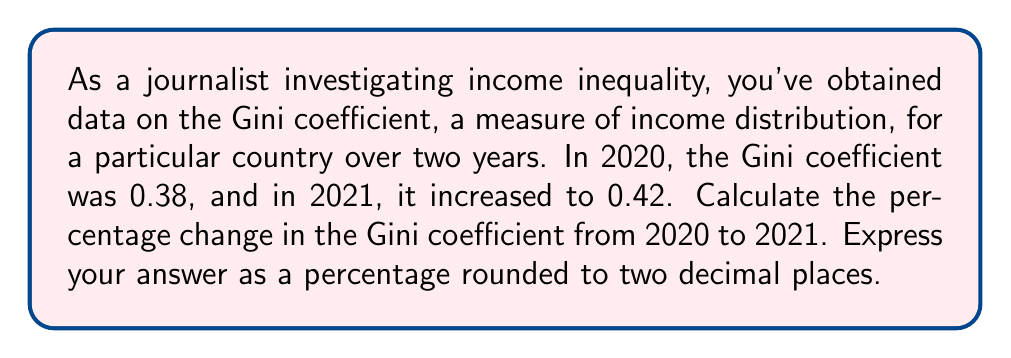Can you answer this question? To calculate the percentage change in the Gini coefficient, we'll use the following formula:

$$ \text{Percentage Change} = \frac{\text{New Value} - \text{Original Value}}{\text{Original Value}} \times 100\% $$

Let's plug in our values:
- Original Value (2020 Gini coefficient): 0.38
- New Value (2021 Gini coefficient): 0.42

$$ \text{Percentage Change} = \frac{0.42 - 0.38}{0.38} \times 100\% $$

$$ = \frac{0.04}{0.38} \times 100\% $$

$$ = 0.10526... \times 100\% $$

$$ = 10.526...\% $$

Rounding to two decimal places, we get 10.53%.

This increase in the Gini coefficient indicates a rise in income inequality over the one-year period, which could be a significant finding for a journalist reporting on social inequality trends.
Answer: 10.53% 